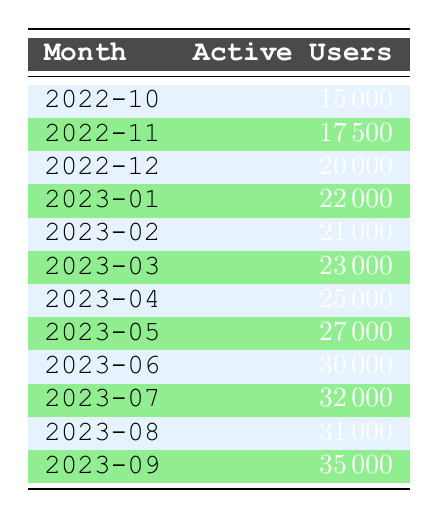What was the active user count for CodeMaster in March 2023? Referring to the table, we can see the row for March 2023 shows 23000 active users.
Answer: 23000 Which month had the highest number of active users for CodeMaster? By looking at the table, September 2023 has the highest count with 35000 active users.
Answer: September 2023 What is the difference in active users between May 2023 and January 2023? In May 2023, there are 27000 active users and in January 2023, there are 22000. The difference is 27000 - 22000 = 5000.
Answer: 5000 Is there a month where the active users decreased compared to the previous month? From the table, we can observe that February 2023 has 21000 active users which is less than January 2023's 22000, indicating a decrease.
Answer: Yes What is the average number of active users for the months between January 2023 and June 2023? The active users for these months are: January (22000), February (21000), March (23000), April (25000), May (27000), June (30000). Adding these gives 22000 + 21000 + 23000 + 25000 + 27000 + 30000 = 148000. There are 6 months, so the average is 148000 / 6 = 24666.67.
Answer: 24666.67 How many active users were gained from June 2023 to September 2023? In June 2023, there were 30000 active users, and in September 2023, there are 35000. The gain is 35000 - 30000 = 5000.
Answer: 5000 Did the app CodeMaster experience consistent growth every month? By inspecting the table, while the app showed growth generally, there was a decrease from January 2023 to February 2023, showing it did not grow consistently.
Answer: No What was the percentage increase in active users from October 2022 to June 2023? October 2022 had 15000 active users, and June 2023 had 30000. The increase is 30000 - 15000 = 15000. The percentage increase is (15000 / 15000) * 100 = 100%.
Answer: 100% 